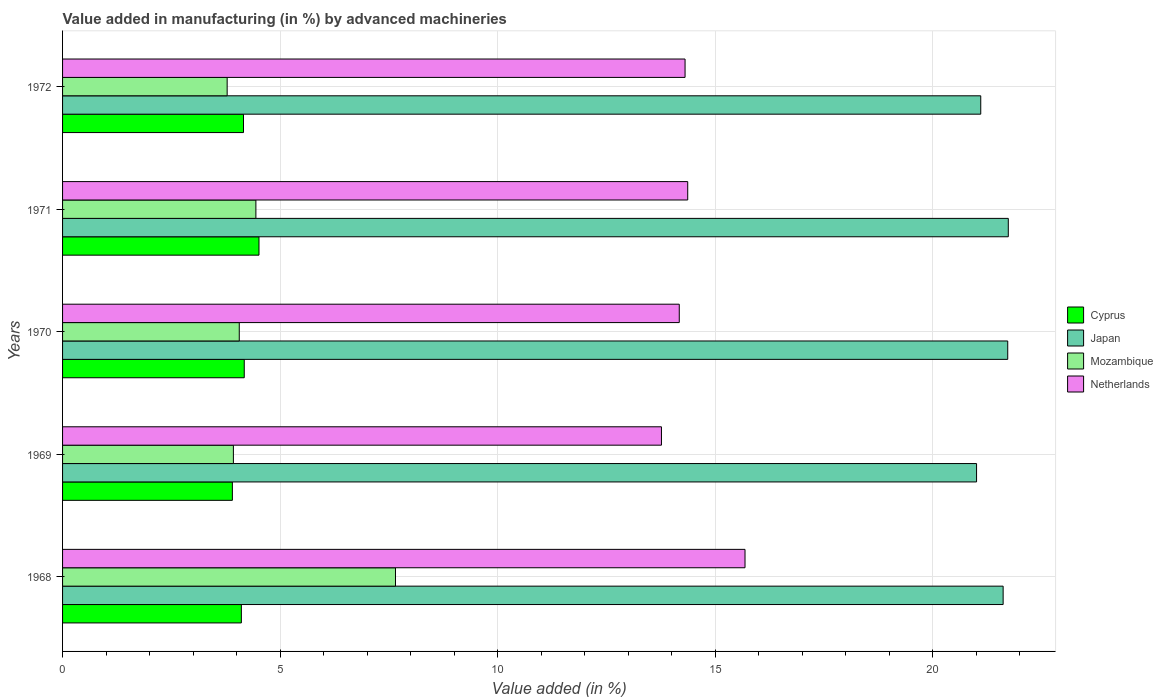How many different coloured bars are there?
Ensure brevity in your answer.  4. Are the number of bars per tick equal to the number of legend labels?
Provide a short and direct response. Yes. What is the label of the 4th group of bars from the top?
Provide a succinct answer. 1969. In how many cases, is the number of bars for a given year not equal to the number of legend labels?
Make the answer very short. 0. What is the percentage of value added in manufacturing by advanced machineries in Japan in 1969?
Your answer should be compact. 21.01. Across all years, what is the maximum percentage of value added in manufacturing by advanced machineries in Cyprus?
Make the answer very short. 4.52. Across all years, what is the minimum percentage of value added in manufacturing by advanced machineries in Netherlands?
Make the answer very short. 13.77. In which year was the percentage of value added in manufacturing by advanced machineries in Cyprus maximum?
Provide a succinct answer. 1971. In which year was the percentage of value added in manufacturing by advanced machineries in Japan minimum?
Your response must be concise. 1969. What is the total percentage of value added in manufacturing by advanced machineries in Netherlands in the graph?
Give a very brief answer. 72.31. What is the difference between the percentage of value added in manufacturing by advanced machineries in Japan in 1971 and that in 1972?
Ensure brevity in your answer.  0.63. What is the difference between the percentage of value added in manufacturing by advanced machineries in Netherlands in 1971 and the percentage of value added in manufacturing by advanced machineries in Japan in 1968?
Provide a short and direct response. -7.25. What is the average percentage of value added in manufacturing by advanced machineries in Japan per year?
Give a very brief answer. 21.44. In the year 1971, what is the difference between the percentage of value added in manufacturing by advanced machineries in Mozambique and percentage of value added in manufacturing by advanced machineries in Netherlands?
Keep it short and to the point. -9.93. In how many years, is the percentage of value added in manufacturing by advanced machineries in Mozambique greater than 14 %?
Your answer should be compact. 0. What is the ratio of the percentage of value added in manufacturing by advanced machineries in Cyprus in 1969 to that in 1972?
Your answer should be compact. 0.94. Is the percentage of value added in manufacturing by advanced machineries in Netherlands in 1968 less than that in 1969?
Offer a terse response. No. What is the difference between the highest and the second highest percentage of value added in manufacturing by advanced machineries in Cyprus?
Your answer should be compact. 0.34. What is the difference between the highest and the lowest percentage of value added in manufacturing by advanced machineries in Japan?
Give a very brief answer. 0.73. In how many years, is the percentage of value added in manufacturing by advanced machineries in Netherlands greater than the average percentage of value added in manufacturing by advanced machineries in Netherlands taken over all years?
Offer a very short reply. 1. What does the 3rd bar from the bottom in 1970 represents?
Offer a terse response. Mozambique. Are all the bars in the graph horizontal?
Your answer should be very brief. Yes. What is the difference between two consecutive major ticks on the X-axis?
Give a very brief answer. 5. Are the values on the major ticks of X-axis written in scientific E-notation?
Give a very brief answer. No. Does the graph contain any zero values?
Keep it short and to the point. No. Does the graph contain grids?
Offer a terse response. Yes. Where does the legend appear in the graph?
Make the answer very short. Center right. How many legend labels are there?
Your answer should be compact. 4. What is the title of the graph?
Your answer should be very brief. Value added in manufacturing (in %) by advanced machineries. What is the label or title of the X-axis?
Your answer should be very brief. Value added (in %). What is the label or title of the Y-axis?
Keep it short and to the point. Years. What is the Value added (in %) in Cyprus in 1968?
Make the answer very short. 4.11. What is the Value added (in %) of Japan in 1968?
Your answer should be compact. 21.62. What is the Value added (in %) of Mozambique in 1968?
Give a very brief answer. 7.65. What is the Value added (in %) of Netherlands in 1968?
Keep it short and to the point. 15.69. What is the Value added (in %) of Cyprus in 1969?
Keep it short and to the point. 3.9. What is the Value added (in %) in Japan in 1969?
Offer a terse response. 21.01. What is the Value added (in %) in Mozambique in 1969?
Provide a succinct answer. 3.93. What is the Value added (in %) of Netherlands in 1969?
Provide a short and direct response. 13.77. What is the Value added (in %) of Cyprus in 1970?
Your answer should be compact. 4.18. What is the Value added (in %) of Japan in 1970?
Give a very brief answer. 21.73. What is the Value added (in %) in Mozambique in 1970?
Provide a short and direct response. 4.06. What is the Value added (in %) of Netherlands in 1970?
Provide a short and direct response. 14.18. What is the Value added (in %) in Cyprus in 1971?
Keep it short and to the point. 4.52. What is the Value added (in %) in Japan in 1971?
Ensure brevity in your answer.  21.74. What is the Value added (in %) of Mozambique in 1971?
Provide a succinct answer. 4.44. What is the Value added (in %) of Netherlands in 1971?
Keep it short and to the point. 14.37. What is the Value added (in %) of Cyprus in 1972?
Provide a short and direct response. 4.16. What is the Value added (in %) of Japan in 1972?
Offer a terse response. 21.11. What is the Value added (in %) in Mozambique in 1972?
Provide a succinct answer. 3.78. What is the Value added (in %) in Netherlands in 1972?
Your response must be concise. 14.31. Across all years, what is the maximum Value added (in %) in Cyprus?
Provide a succinct answer. 4.52. Across all years, what is the maximum Value added (in %) in Japan?
Give a very brief answer. 21.74. Across all years, what is the maximum Value added (in %) of Mozambique?
Ensure brevity in your answer.  7.65. Across all years, what is the maximum Value added (in %) of Netherlands?
Your response must be concise. 15.69. Across all years, what is the minimum Value added (in %) in Cyprus?
Give a very brief answer. 3.9. Across all years, what is the minimum Value added (in %) in Japan?
Keep it short and to the point. 21.01. Across all years, what is the minimum Value added (in %) in Mozambique?
Make the answer very short. 3.78. Across all years, what is the minimum Value added (in %) in Netherlands?
Your answer should be compact. 13.77. What is the total Value added (in %) in Cyprus in the graph?
Keep it short and to the point. 20.86. What is the total Value added (in %) of Japan in the graph?
Make the answer very short. 107.2. What is the total Value added (in %) of Mozambique in the graph?
Your answer should be very brief. 23.87. What is the total Value added (in %) of Netherlands in the graph?
Your answer should be very brief. 72.31. What is the difference between the Value added (in %) in Cyprus in 1968 and that in 1969?
Ensure brevity in your answer.  0.21. What is the difference between the Value added (in %) in Japan in 1968 and that in 1969?
Make the answer very short. 0.61. What is the difference between the Value added (in %) in Mozambique in 1968 and that in 1969?
Your answer should be compact. 3.73. What is the difference between the Value added (in %) of Netherlands in 1968 and that in 1969?
Keep it short and to the point. 1.92. What is the difference between the Value added (in %) in Cyprus in 1968 and that in 1970?
Provide a succinct answer. -0.07. What is the difference between the Value added (in %) in Japan in 1968 and that in 1970?
Your answer should be compact. -0.11. What is the difference between the Value added (in %) of Mozambique in 1968 and that in 1970?
Provide a short and direct response. 3.59. What is the difference between the Value added (in %) of Netherlands in 1968 and that in 1970?
Ensure brevity in your answer.  1.51. What is the difference between the Value added (in %) in Cyprus in 1968 and that in 1971?
Give a very brief answer. -0.41. What is the difference between the Value added (in %) of Japan in 1968 and that in 1971?
Make the answer very short. -0.12. What is the difference between the Value added (in %) in Mozambique in 1968 and that in 1971?
Offer a terse response. 3.21. What is the difference between the Value added (in %) in Netherlands in 1968 and that in 1971?
Offer a terse response. 1.32. What is the difference between the Value added (in %) in Cyprus in 1968 and that in 1972?
Ensure brevity in your answer.  -0.05. What is the difference between the Value added (in %) in Japan in 1968 and that in 1972?
Give a very brief answer. 0.51. What is the difference between the Value added (in %) in Mozambique in 1968 and that in 1972?
Your answer should be very brief. 3.87. What is the difference between the Value added (in %) of Netherlands in 1968 and that in 1972?
Keep it short and to the point. 1.38. What is the difference between the Value added (in %) in Cyprus in 1969 and that in 1970?
Make the answer very short. -0.27. What is the difference between the Value added (in %) in Japan in 1969 and that in 1970?
Keep it short and to the point. -0.72. What is the difference between the Value added (in %) of Mozambique in 1969 and that in 1970?
Your answer should be compact. -0.14. What is the difference between the Value added (in %) of Netherlands in 1969 and that in 1970?
Offer a terse response. -0.41. What is the difference between the Value added (in %) in Cyprus in 1969 and that in 1971?
Your response must be concise. -0.61. What is the difference between the Value added (in %) of Japan in 1969 and that in 1971?
Give a very brief answer. -0.73. What is the difference between the Value added (in %) in Mozambique in 1969 and that in 1971?
Your answer should be very brief. -0.52. What is the difference between the Value added (in %) of Netherlands in 1969 and that in 1971?
Your response must be concise. -0.6. What is the difference between the Value added (in %) in Cyprus in 1969 and that in 1972?
Provide a succinct answer. -0.26. What is the difference between the Value added (in %) in Japan in 1969 and that in 1972?
Your response must be concise. -0.1. What is the difference between the Value added (in %) of Mozambique in 1969 and that in 1972?
Provide a short and direct response. 0.14. What is the difference between the Value added (in %) in Netherlands in 1969 and that in 1972?
Offer a terse response. -0.54. What is the difference between the Value added (in %) in Cyprus in 1970 and that in 1971?
Give a very brief answer. -0.34. What is the difference between the Value added (in %) in Japan in 1970 and that in 1971?
Your response must be concise. -0.01. What is the difference between the Value added (in %) in Mozambique in 1970 and that in 1971?
Ensure brevity in your answer.  -0.38. What is the difference between the Value added (in %) in Netherlands in 1970 and that in 1971?
Offer a terse response. -0.19. What is the difference between the Value added (in %) of Cyprus in 1970 and that in 1972?
Your answer should be compact. 0.02. What is the difference between the Value added (in %) in Japan in 1970 and that in 1972?
Provide a succinct answer. 0.62. What is the difference between the Value added (in %) of Mozambique in 1970 and that in 1972?
Provide a succinct answer. 0.28. What is the difference between the Value added (in %) in Netherlands in 1970 and that in 1972?
Offer a terse response. -0.13. What is the difference between the Value added (in %) in Cyprus in 1971 and that in 1972?
Ensure brevity in your answer.  0.36. What is the difference between the Value added (in %) in Japan in 1971 and that in 1972?
Your answer should be very brief. 0.63. What is the difference between the Value added (in %) in Mozambique in 1971 and that in 1972?
Your response must be concise. 0.66. What is the difference between the Value added (in %) of Netherlands in 1971 and that in 1972?
Offer a very short reply. 0.06. What is the difference between the Value added (in %) in Cyprus in 1968 and the Value added (in %) in Japan in 1969?
Provide a succinct answer. -16.9. What is the difference between the Value added (in %) in Cyprus in 1968 and the Value added (in %) in Mozambique in 1969?
Offer a terse response. 0.18. What is the difference between the Value added (in %) of Cyprus in 1968 and the Value added (in %) of Netherlands in 1969?
Offer a terse response. -9.66. What is the difference between the Value added (in %) of Japan in 1968 and the Value added (in %) of Mozambique in 1969?
Your answer should be compact. 17.69. What is the difference between the Value added (in %) of Japan in 1968 and the Value added (in %) of Netherlands in 1969?
Provide a short and direct response. 7.85. What is the difference between the Value added (in %) of Mozambique in 1968 and the Value added (in %) of Netherlands in 1969?
Your answer should be very brief. -6.11. What is the difference between the Value added (in %) in Cyprus in 1968 and the Value added (in %) in Japan in 1970?
Offer a very short reply. -17.62. What is the difference between the Value added (in %) in Cyprus in 1968 and the Value added (in %) in Mozambique in 1970?
Your answer should be very brief. 0.05. What is the difference between the Value added (in %) in Cyprus in 1968 and the Value added (in %) in Netherlands in 1970?
Keep it short and to the point. -10.07. What is the difference between the Value added (in %) in Japan in 1968 and the Value added (in %) in Mozambique in 1970?
Your answer should be very brief. 17.56. What is the difference between the Value added (in %) in Japan in 1968 and the Value added (in %) in Netherlands in 1970?
Your answer should be compact. 7.44. What is the difference between the Value added (in %) in Mozambique in 1968 and the Value added (in %) in Netherlands in 1970?
Your response must be concise. -6.52. What is the difference between the Value added (in %) of Cyprus in 1968 and the Value added (in %) of Japan in 1971?
Ensure brevity in your answer.  -17.63. What is the difference between the Value added (in %) of Cyprus in 1968 and the Value added (in %) of Mozambique in 1971?
Offer a very short reply. -0.33. What is the difference between the Value added (in %) of Cyprus in 1968 and the Value added (in %) of Netherlands in 1971?
Keep it short and to the point. -10.26. What is the difference between the Value added (in %) in Japan in 1968 and the Value added (in %) in Mozambique in 1971?
Offer a very short reply. 17.18. What is the difference between the Value added (in %) of Japan in 1968 and the Value added (in %) of Netherlands in 1971?
Your answer should be very brief. 7.25. What is the difference between the Value added (in %) in Mozambique in 1968 and the Value added (in %) in Netherlands in 1971?
Your response must be concise. -6.72. What is the difference between the Value added (in %) of Cyprus in 1968 and the Value added (in %) of Japan in 1972?
Keep it short and to the point. -17. What is the difference between the Value added (in %) in Cyprus in 1968 and the Value added (in %) in Mozambique in 1972?
Offer a terse response. 0.33. What is the difference between the Value added (in %) of Cyprus in 1968 and the Value added (in %) of Netherlands in 1972?
Provide a short and direct response. -10.2. What is the difference between the Value added (in %) in Japan in 1968 and the Value added (in %) in Mozambique in 1972?
Give a very brief answer. 17.84. What is the difference between the Value added (in %) in Japan in 1968 and the Value added (in %) in Netherlands in 1972?
Your response must be concise. 7.31. What is the difference between the Value added (in %) in Mozambique in 1968 and the Value added (in %) in Netherlands in 1972?
Provide a short and direct response. -6.66. What is the difference between the Value added (in %) of Cyprus in 1969 and the Value added (in %) of Japan in 1970?
Offer a very short reply. -17.82. What is the difference between the Value added (in %) of Cyprus in 1969 and the Value added (in %) of Mozambique in 1970?
Offer a terse response. -0.16. What is the difference between the Value added (in %) in Cyprus in 1969 and the Value added (in %) in Netherlands in 1970?
Keep it short and to the point. -10.27. What is the difference between the Value added (in %) in Japan in 1969 and the Value added (in %) in Mozambique in 1970?
Your answer should be very brief. 16.95. What is the difference between the Value added (in %) of Japan in 1969 and the Value added (in %) of Netherlands in 1970?
Offer a very short reply. 6.83. What is the difference between the Value added (in %) in Mozambique in 1969 and the Value added (in %) in Netherlands in 1970?
Make the answer very short. -10.25. What is the difference between the Value added (in %) of Cyprus in 1969 and the Value added (in %) of Japan in 1971?
Your answer should be compact. -17.84. What is the difference between the Value added (in %) of Cyprus in 1969 and the Value added (in %) of Mozambique in 1971?
Provide a succinct answer. -0.54. What is the difference between the Value added (in %) in Cyprus in 1969 and the Value added (in %) in Netherlands in 1971?
Make the answer very short. -10.47. What is the difference between the Value added (in %) in Japan in 1969 and the Value added (in %) in Mozambique in 1971?
Offer a very short reply. 16.57. What is the difference between the Value added (in %) of Japan in 1969 and the Value added (in %) of Netherlands in 1971?
Provide a succinct answer. 6.64. What is the difference between the Value added (in %) in Mozambique in 1969 and the Value added (in %) in Netherlands in 1971?
Offer a terse response. -10.44. What is the difference between the Value added (in %) in Cyprus in 1969 and the Value added (in %) in Japan in 1972?
Your response must be concise. -17.2. What is the difference between the Value added (in %) of Cyprus in 1969 and the Value added (in %) of Mozambique in 1972?
Your response must be concise. 0.12. What is the difference between the Value added (in %) in Cyprus in 1969 and the Value added (in %) in Netherlands in 1972?
Make the answer very short. -10.41. What is the difference between the Value added (in %) of Japan in 1969 and the Value added (in %) of Mozambique in 1972?
Offer a terse response. 17.23. What is the difference between the Value added (in %) in Japan in 1969 and the Value added (in %) in Netherlands in 1972?
Provide a succinct answer. 6.7. What is the difference between the Value added (in %) in Mozambique in 1969 and the Value added (in %) in Netherlands in 1972?
Give a very brief answer. -10.38. What is the difference between the Value added (in %) in Cyprus in 1970 and the Value added (in %) in Japan in 1971?
Your answer should be compact. -17.56. What is the difference between the Value added (in %) in Cyprus in 1970 and the Value added (in %) in Mozambique in 1971?
Offer a terse response. -0.27. What is the difference between the Value added (in %) of Cyprus in 1970 and the Value added (in %) of Netherlands in 1971?
Ensure brevity in your answer.  -10.19. What is the difference between the Value added (in %) in Japan in 1970 and the Value added (in %) in Mozambique in 1971?
Offer a terse response. 17.28. What is the difference between the Value added (in %) of Japan in 1970 and the Value added (in %) of Netherlands in 1971?
Ensure brevity in your answer.  7.36. What is the difference between the Value added (in %) in Mozambique in 1970 and the Value added (in %) in Netherlands in 1971?
Provide a short and direct response. -10.31. What is the difference between the Value added (in %) of Cyprus in 1970 and the Value added (in %) of Japan in 1972?
Your answer should be very brief. -16.93. What is the difference between the Value added (in %) in Cyprus in 1970 and the Value added (in %) in Mozambique in 1972?
Your response must be concise. 0.39. What is the difference between the Value added (in %) of Cyprus in 1970 and the Value added (in %) of Netherlands in 1972?
Provide a succinct answer. -10.13. What is the difference between the Value added (in %) in Japan in 1970 and the Value added (in %) in Mozambique in 1972?
Make the answer very short. 17.94. What is the difference between the Value added (in %) in Japan in 1970 and the Value added (in %) in Netherlands in 1972?
Provide a succinct answer. 7.42. What is the difference between the Value added (in %) of Mozambique in 1970 and the Value added (in %) of Netherlands in 1972?
Give a very brief answer. -10.25. What is the difference between the Value added (in %) of Cyprus in 1971 and the Value added (in %) of Japan in 1972?
Make the answer very short. -16.59. What is the difference between the Value added (in %) of Cyprus in 1971 and the Value added (in %) of Mozambique in 1972?
Keep it short and to the point. 0.73. What is the difference between the Value added (in %) in Cyprus in 1971 and the Value added (in %) in Netherlands in 1972?
Offer a very short reply. -9.79. What is the difference between the Value added (in %) of Japan in 1971 and the Value added (in %) of Mozambique in 1972?
Your answer should be compact. 17.96. What is the difference between the Value added (in %) in Japan in 1971 and the Value added (in %) in Netherlands in 1972?
Give a very brief answer. 7.43. What is the difference between the Value added (in %) of Mozambique in 1971 and the Value added (in %) of Netherlands in 1972?
Your response must be concise. -9.87. What is the average Value added (in %) of Cyprus per year?
Make the answer very short. 4.17. What is the average Value added (in %) of Japan per year?
Provide a succinct answer. 21.44. What is the average Value added (in %) of Mozambique per year?
Provide a short and direct response. 4.77. What is the average Value added (in %) in Netherlands per year?
Give a very brief answer. 14.46. In the year 1968, what is the difference between the Value added (in %) of Cyprus and Value added (in %) of Japan?
Your response must be concise. -17.51. In the year 1968, what is the difference between the Value added (in %) of Cyprus and Value added (in %) of Mozambique?
Offer a terse response. -3.54. In the year 1968, what is the difference between the Value added (in %) in Cyprus and Value added (in %) in Netherlands?
Your response must be concise. -11.58. In the year 1968, what is the difference between the Value added (in %) of Japan and Value added (in %) of Mozambique?
Make the answer very short. 13.97. In the year 1968, what is the difference between the Value added (in %) of Japan and Value added (in %) of Netherlands?
Provide a succinct answer. 5.93. In the year 1968, what is the difference between the Value added (in %) in Mozambique and Value added (in %) in Netherlands?
Offer a very short reply. -8.03. In the year 1969, what is the difference between the Value added (in %) of Cyprus and Value added (in %) of Japan?
Your answer should be very brief. -17.11. In the year 1969, what is the difference between the Value added (in %) in Cyprus and Value added (in %) in Mozambique?
Keep it short and to the point. -0.02. In the year 1969, what is the difference between the Value added (in %) of Cyprus and Value added (in %) of Netherlands?
Offer a terse response. -9.86. In the year 1969, what is the difference between the Value added (in %) in Japan and Value added (in %) in Mozambique?
Give a very brief answer. 17.08. In the year 1969, what is the difference between the Value added (in %) of Japan and Value added (in %) of Netherlands?
Give a very brief answer. 7.24. In the year 1969, what is the difference between the Value added (in %) in Mozambique and Value added (in %) in Netherlands?
Your response must be concise. -9.84. In the year 1970, what is the difference between the Value added (in %) of Cyprus and Value added (in %) of Japan?
Provide a succinct answer. -17.55. In the year 1970, what is the difference between the Value added (in %) of Cyprus and Value added (in %) of Mozambique?
Your answer should be compact. 0.11. In the year 1970, what is the difference between the Value added (in %) of Cyprus and Value added (in %) of Netherlands?
Keep it short and to the point. -10. In the year 1970, what is the difference between the Value added (in %) of Japan and Value added (in %) of Mozambique?
Ensure brevity in your answer.  17.67. In the year 1970, what is the difference between the Value added (in %) in Japan and Value added (in %) in Netherlands?
Keep it short and to the point. 7.55. In the year 1970, what is the difference between the Value added (in %) of Mozambique and Value added (in %) of Netherlands?
Your answer should be very brief. -10.11. In the year 1971, what is the difference between the Value added (in %) in Cyprus and Value added (in %) in Japan?
Your answer should be very brief. -17.22. In the year 1971, what is the difference between the Value added (in %) of Cyprus and Value added (in %) of Mozambique?
Offer a terse response. 0.07. In the year 1971, what is the difference between the Value added (in %) of Cyprus and Value added (in %) of Netherlands?
Make the answer very short. -9.86. In the year 1971, what is the difference between the Value added (in %) in Japan and Value added (in %) in Mozambique?
Provide a short and direct response. 17.3. In the year 1971, what is the difference between the Value added (in %) in Japan and Value added (in %) in Netherlands?
Provide a short and direct response. 7.37. In the year 1971, what is the difference between the Value added (in %) in Mozambique and Value added (in %) in Netherlands?
Offer a very short reply. -9.93. In the year 1972, what is the difference between the Value added (in %) in Cyprus and Value added (in %) in Japan?
Make the answer very short. -16.95. In the year 1972, what is the difference between the Value added (in %) in Cyprus and Value added (in %) in Mozambique?
Your response must be concise. 0.38. In the year 1972, what is the difference between the Value added (in %) of Cyprus and Value added (in %) of Netherlands?
Keep it short and to the point. -10.15. In the year 1972, what is the difference between the Value added (in %) in Japan and Value added (in %) in Mozambique?
Your response must be concise. 17.32. In the year 1972, what is the difference between the Value added (in %) of Japan and Value added (in %) of Netherlands?
Provide a short and direct response. 6.8. In the year 1972, what is the difference between the Value added (in %) in Mozambique and Value added (in %) in Netherlands?
Offer a very short reply. -10.53. What is the ratio of the Value added (in %) of Cyprus in 1968 to that in 1969?
Your answer should be very brief. 1.05. What is the ratio of the Value added (in %) of Japan in 1968 to that in 1969?
Provide a succinct answer. 1.03. What is the ratio of the Value added (in %) in Mozambique in 1968 to that in 1969?
Give a very brief answer. 1.95. What is the ratio of the Value added (in %) in Netherlands in 1968 to that in 1969?
Make the answer very short. 1.14. What is the ratio of the Value added (in %) in Cyprus in 1968 to that in 1970?
Provide a succinct answer. 0.98. What is the ratio of the Value added (in %) of Japan in 1968 to that in 1970?
Make the answer very short. 1. What is the ratio of the Value added (in %) of Mozambique in 1968 to that in 1970?
Give a very brief answer. 1.88. What is the ratio of the Value added (in %) of Netherlands in 1968 to that in 1970?
Your response must be concise. 1.11. What is the ratio of the Value added (in %) in Cyprus in 1968 to that in 1971?
Offer a terse response. 0.91. What is the ratio of the Value added (in %) in Japan in 1968 to that in 1971?
Provide a short and direct response. 0.99. What is the ratio of the Value added (in %) of Mozambique in 1968 to that in 1971?
Offer a very short reply. 1.72. What is the ratio of the Value added (in %) in Netherlands in 1968 to that in 1971?
Your answer should be compact. 1.09. What is the ratio of the Value added (in %) in Cyprus in 1968 to that in 1972?
Ensure brevity in your answer.  0.99. What is the ratio of the Value added (in %) in Japan in 1968 to that in 1972?
Your answer should be compact. 1.02. What is the ratio of the Value added (in %) of Mozambique in 1968 to that in 1972?
Ensure brevity in your answer.  2.02. What is the ratio of the Value added (in %) in Netherlands in 1968 to that in 1972?
Offer a terse response. 1.1. What is the ratio of the Value added (in %) in Cyprus in 1969 to that in 1970?
Your response must be concise. 0.93. What is the ratio of the Value added (in %) in Japan in 1969 to that in 1970?
Keep it short and to the point. 0.97. What is the ratio of the Value added (in %) in Mozambique in 1969 to that in 1970?
Give a very brief answer. 0.97. What is the ratio of the Value added (in %) in Netherlands in 1969 to that in 1970?
Offer a terse response. 0.97. What is the ratio of the Value added (in %) of Cyprus in 1969 to that in 1971?
Keep it short and to the point. 0.86. What is the ratio of the Value added (in %) in Japan in 1969 to that in 1971?
Ensure brevity in your answer.  0.97. What is the ratio of the Value added (in %) in Mozambique in 1969 to that in 1971?
Ensure brevity in your answer.  0.88. What is the ratio of the Value added (in %) in Netherlands in 1969 to that in 1971?
Offer a very short reply. 0.96. What is the ratio of the Value added (in %) of Cyprus in 1969 to that in 1972?
Offer a very short reply. 0.94. What is the ratio of the Value added (in %) of Japan in 1969 to that in 1972?
Make the answer very short. 1. What is the ratio of the Value added (in %) in Mozambique in 1969 to that in 1972?
Offer a very short reply. 1.04. What is the ratio of the Value added (in %) in Netherlands in 1969 to that in 1972?
Keep it short and to the point. 0.96. What is the ratio of the Value added (in %) in Cyprus in 1970 to that in 1971?
Your answer should be very brief. 0.93. What is the ratio of the Value added (in %) in Japan in 1970 to that in 1971?
Offer a very short reply. 1. What is the ratio of the Value added (in %) of Mozambique in 1970 to that in 1971?
Your answer should be very brief. 0.91. What is the ratio of the Value added (in %) of Netherlands in 1970 to that in 1971?
Offer a terse response. 0.99. What is the ratio of the Value added (in %) in Japan in 1970 to that in 1972?
Offer a terse response. 1.03. What is the ratio of the Value added (in %) of Mozambique in 1970 to that in 1972?
Offer a terse response. 1.07. What is the ratio of the Value added (in %) in Netherlands in 1970 to that in 1972?
Offer a terse response. 0.99. What is the ratio of the Value added (in %) in Cyprus in 1971 to that in 1972?
Offer a very short reply. 1.09. What is the ratio of the Value added (in %) of Japan in 1971 to that in 1972?
Ensure brevity in your answer.  1.03. What is the ratio of the Value added (in %) in Mozambique in 1971 to that in 1972?
Ensure brevity in your answer.  1.17. What is the difference between the highest and the second highest Value added (in %) of Cyprus?
Keep it short and to the point. 0.34. What is the difference between the highest and the second highest Value added (in %) of Japan?
Your answer should be compact. 0.01. What is the difference between the highest and the second highest Value added (in %) in Mozambique?
Offer a very short reply. 3.21. What is the difference between the highest and the second highest Value added (in %) of Netherlands?
Offer a very short reply. 1.32. What is the difference between the highest and the lowest Value added (in %) in Cyprus?
Your answer should be compact. 0.61. What is the difference between the highest and the lowest Value added (in %) of Japan?
Your response must be concise. 0.73. What is the difference between the highest and the lowest Value added (in %) of Mozambique?
Provide a short and direct response. 3.87. What is the difference between the highest and the lowest Value added (in %) of Netherlands?
Your answer should be very brief. 1.92. 